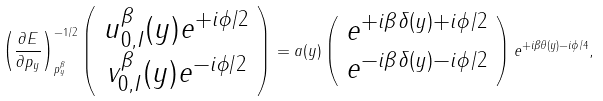<formula> <loc_0><loc_0><loc_500><loc_500>\left ( \frac { \partial E } { \partial p _ { y } } \right ) ^ { - 1 / 2 } _ { p _ { y } ^ { \beta } } \left ( \begin{array} { c } u ^ { \beta } _ { 0 , I } ( y ) e ^ { + i \phi / 2 } \\ v ^ { \beta } _ { 0 , I } ( y ) e ^ { - i \phi / 2 } \end{array} \right ) = a ( y ) \left ( \begin{array} { c } e ^ { + i \beta \delta ( y ) + i \phi / 2 } \\ e ^ { - i \beta \delta ( y ) - i \phi / 2 } \end{array} \right ) e ^ { + i \beta \theta ( y ) - i \phi / 4 } ,</formula> 